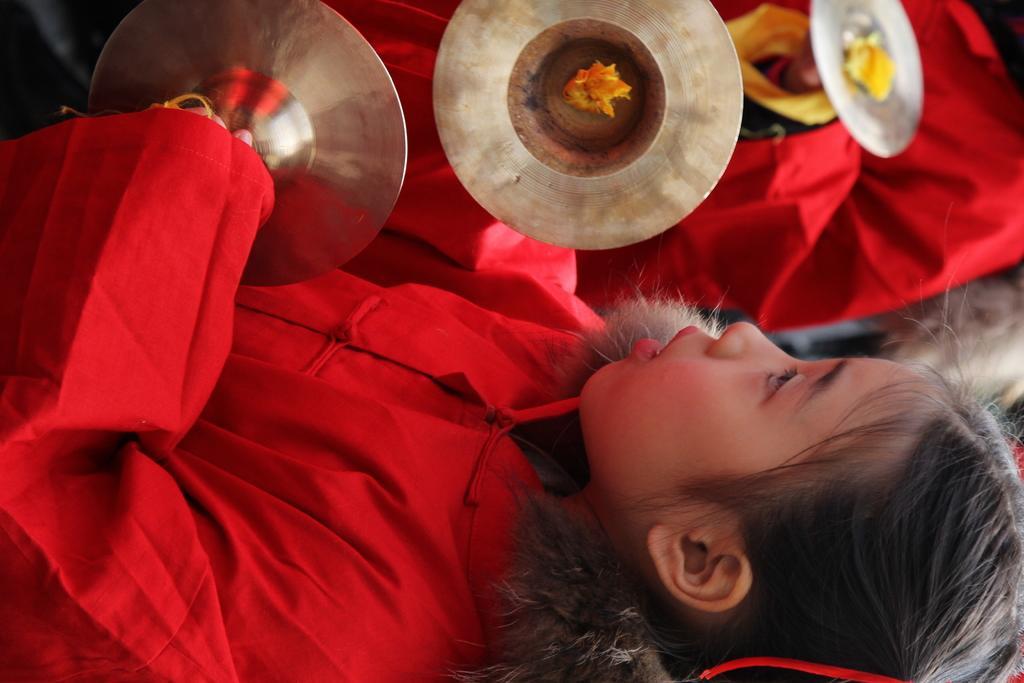How would you summarize this image in a sentence or two? In the picture I can see people among them some of them are wearing red color clothes. The girl in the front is holding musical instruments in hands. 